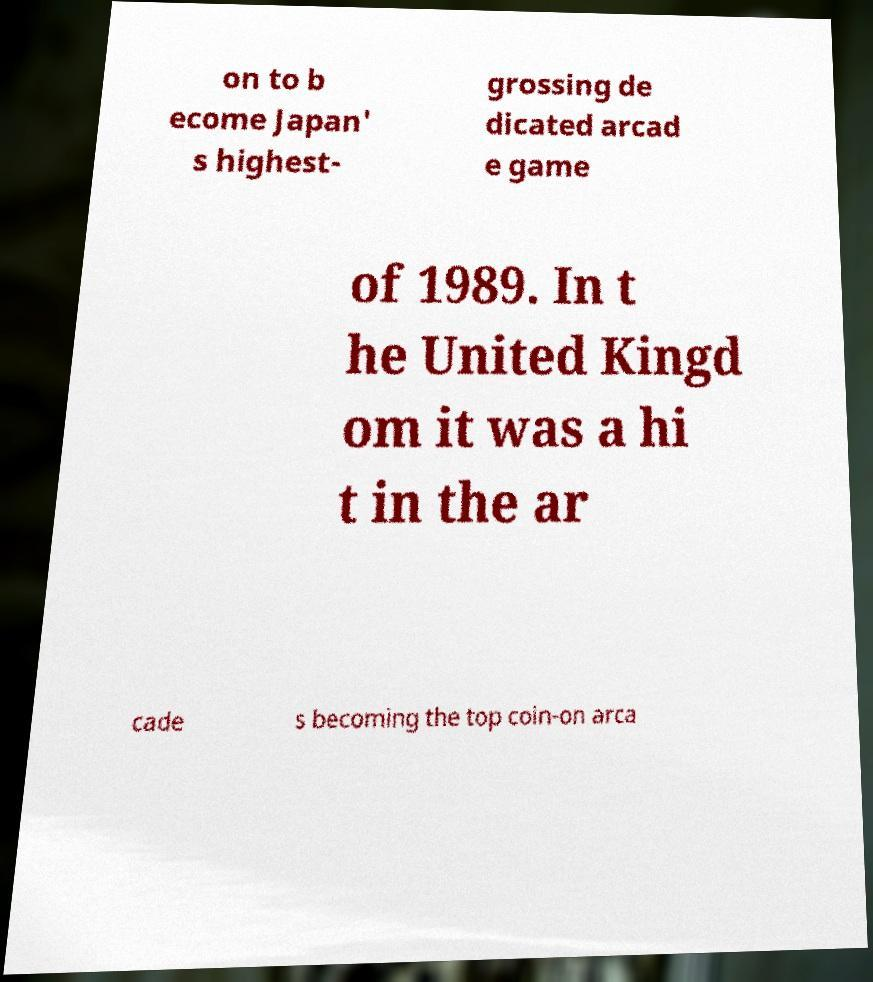For documentation purposes, I need the text within this image transcribed. Could you provide that? on to b ecome Japan' s highest- grossing de dicated arcad e game of 1989. In t he United Kingd om it was a hi t in the ar cade s becoming the top coin-on arca 